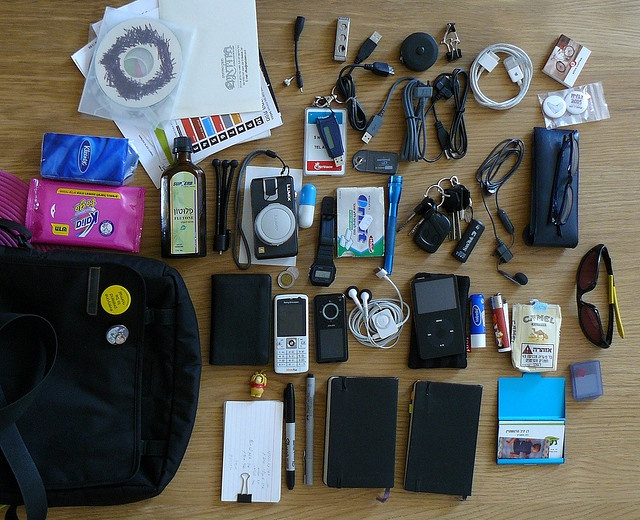Describe the objects in this image and their specific colors. I can see handbag in olive, black, and maroon tones, backpack in olive, black, and gray tones, bottle in olive, black, darkgray, and gray tones, cell phone in olive, black, lightblue, and darkgray tones, and cell phone in olive, black, and purple tones in this image. 